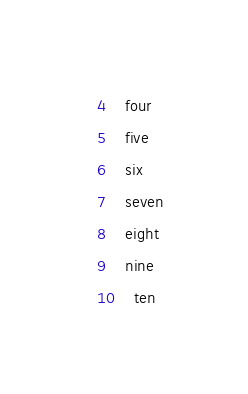<code> <loc_0><loc_0><loc_500><loc_500><_SQL_>4	four
5	five
6	six
7	seven
8	eight
9	nine 
10	ten
</code> 